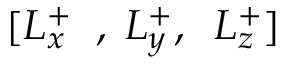<formula> <loc_0><loc_0><loc_500><loc_500>[ L _ { x } ^ { + } \, , \, L _ { y } ^ { + } , \, L _ { z } ^ { + } ]</formula> 